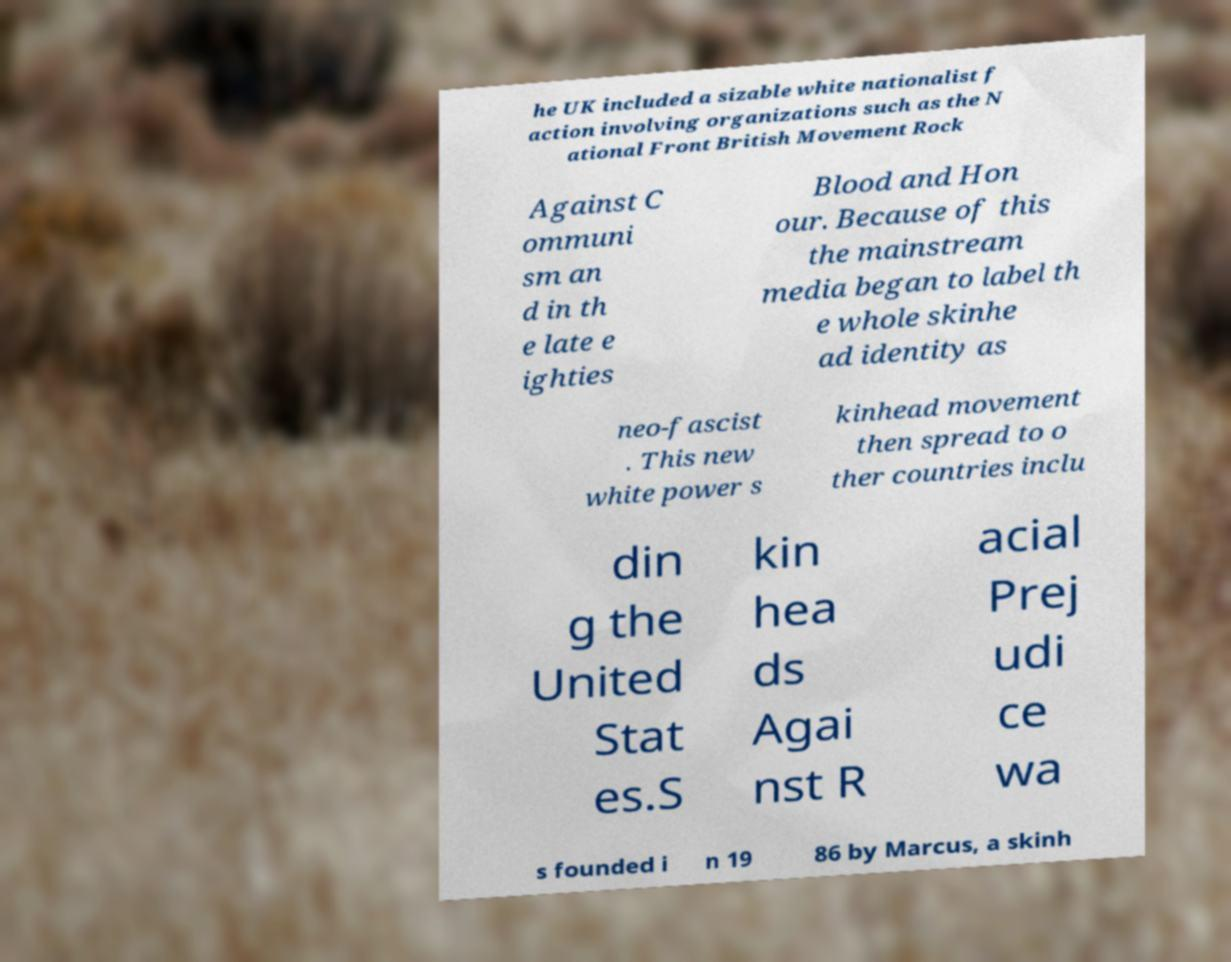Please identify and transcribe the text found in this image. he UK included a sizable white nationalist f action involving organizations such as the N ational Front British Movement Rock Against C ommuni sm an d in th e late e ighties Blood and Hon our. Because of this the mainstream media began to label th e whole skinhe ad identity as neo-fascist . This new white power s kinhead movement then spread to o ther countries inclu din g the United Stat es.S kin hea ds Agai nst R acial Prej udi ce wa s founded i n 19 86 by Marcus, a skinh 